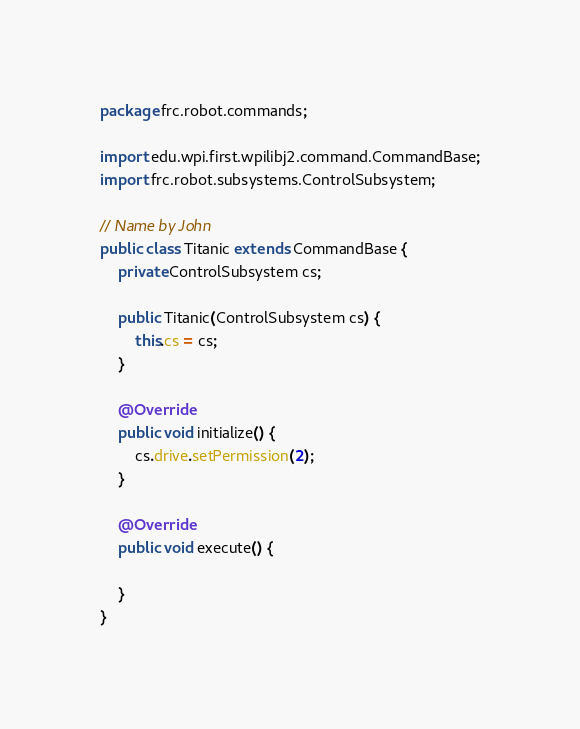Convert code to text. <code><loc_0><loc_0><loc_500><loc_500><_Java_>package frc.robot.commands;

import edu.wpi.first.wpilibj2.command.CommandBase;
import frc.robot.subsystems.ControlSubsystem;

// Name by John
public class Titanic extends CommandBase {
    private ControlSubsystem cs;

    public Titanic(ControlSubsystem cs) {
        this.cs = cs;
    }

    @Override
    public void initialize() {
        cs.drive.setPermission(2);
    }

    @Override
    public void execute() {

    }
}
</code> 